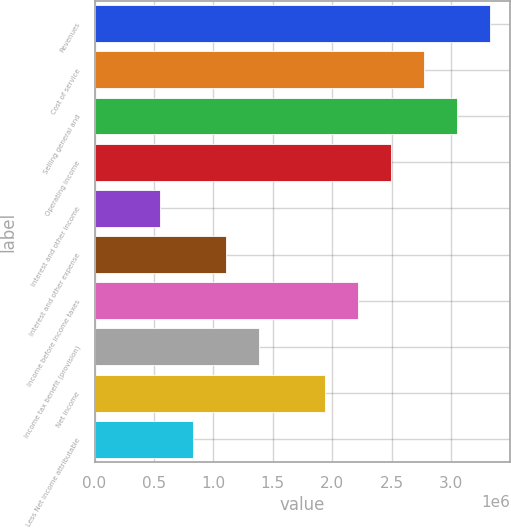Convert chart to OTSL. <chart><loc_0><loc_0><loc_500><loc_500><bar_chart><fcel>Revenues<fcel>Cost of service<fcel>Selling general and<fcel>Operating income<fcel>Interest and other income<fcel>Interest and other expense<fcel>Income before income taxes<fcel>Income tax benefit (provision)<fcel>Net income<fcel>Less Net income attributable<nl><fcel>3.32846e+06<fcel>2.77372e+06<fcel>3.05109e+06<fcel>2.49635e+06<fcel>554745<fcel>1.10949e+06<fcel>2.21897e+06<fcel>1.38686e+06<fcel>1.9416e+06<fcel>832117<nl></chart> 